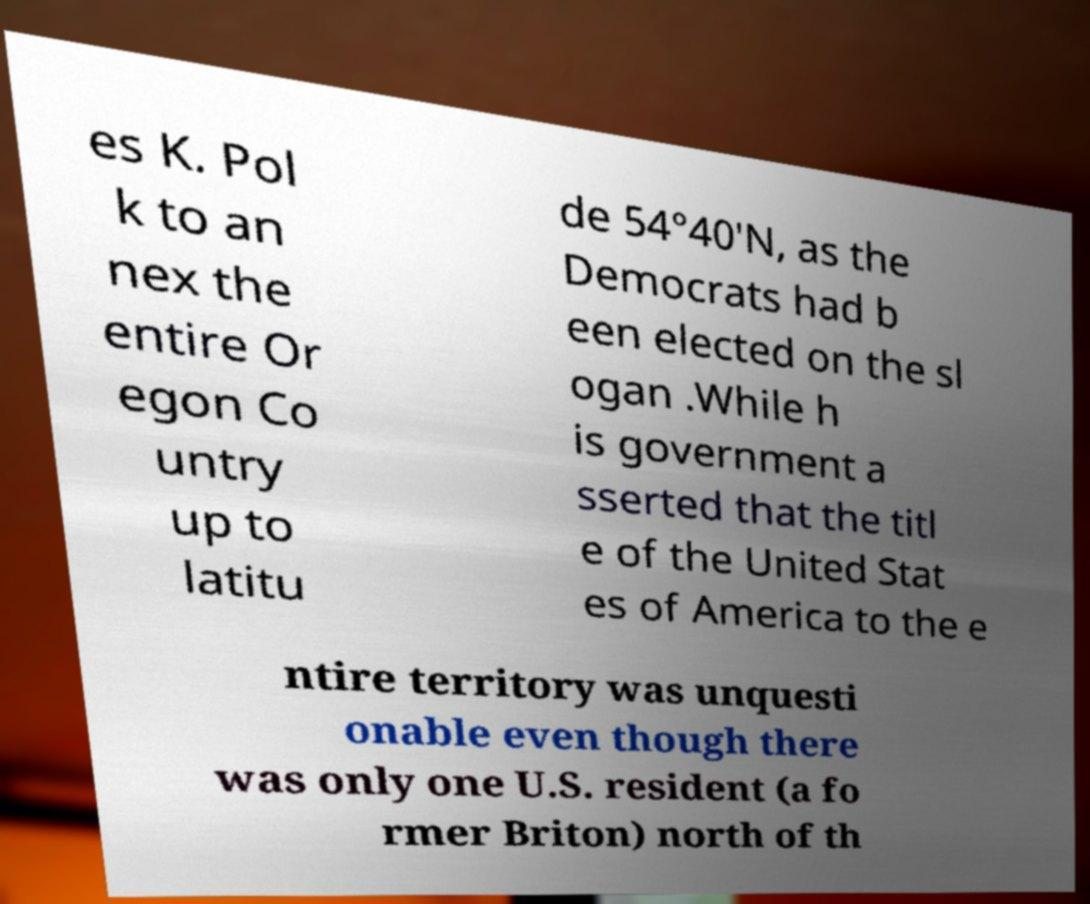I need the written content from this picture converted into text. Can you do that? es K. Pol k to an nex the entire Or egon Co untry up to latitu de 54°40′N, as the Democrats had b een elected on the sl ogan .While h is government a sserted that the titl e of the United Stat es of America to the e ntire territory was unquesti onable even though there was only one U.S. resident (a fo rmer Briton) north of th 